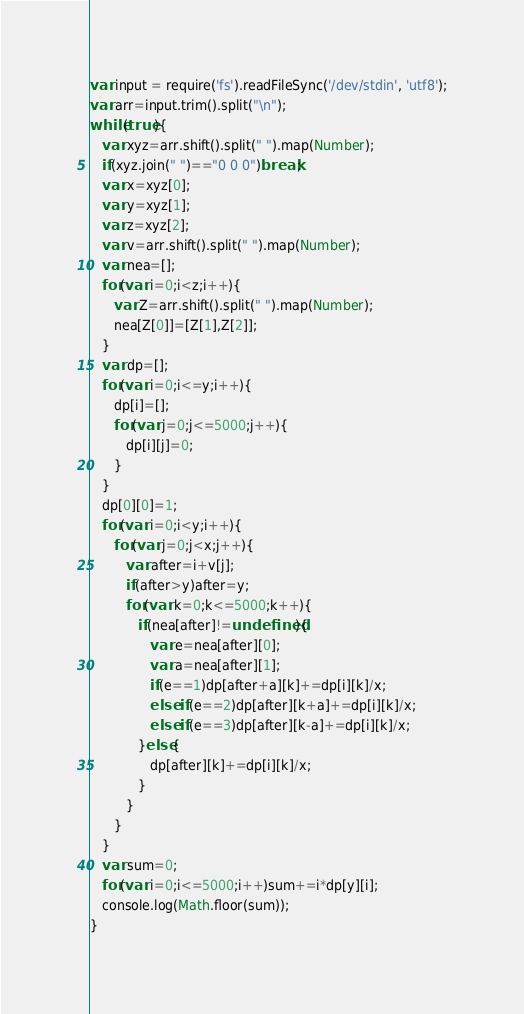<code> <loc_0><loc_0><loc_500><loc_500><_JavaScript_>var input = require('fs').readFileSync('/dev/stdin', 'utf8');
var arr=input.trim().split("\n");
while(true){
   var xyz=arr.shift().split(" ").map(Number);
   if(xyz.join(" ")=="0 0 0")break;
   var x=xyz[0];
   var y=xyz[1];
   var z=xyz[2];
   var v=arr.shift().split(" ").map(Number);
   var nea=[];
   for(var i=0;i<z;i++){
      var Z=arr.shift().split(" ").map(Number);
      nea[Z[0]]=[Z[1],Z[2]];
   }
   var dp=[];
   for(var i=0;i<=y;i++){
      dp[i]=[];
      for(var j=0;j<=5000;j++){
         dp[i][j]=0;
      }
   }
   dp[0][0]=1;
   for(var i=0;i<y;i++){
      for(var j=0;j<x;j++){
         var after=i+v[j];
         if(after>y)after=y;
         for(var k=0;k<=5000;k++){
            if(nea[after]!=undefined){
               var e=nea[after][0];
               var a=nea[after][1];
               if(e==1)dp[after+a][k]+=dp[i][k]/x;
               else if(e==2)dp[after][k+a]+=dp[i][k]/x;
               else if(e==3)dp[after][k-a]+=dp[i][k]/x;
            }else{
               dp[after][k]+=dp[i][k]/x;
            }
         }
      }
   }
   var sum=0;
   for(var i=0;i<=5000;i++)sum+=i*dp[y][i];
   console.log(Math.floor(sum));
}</code> 